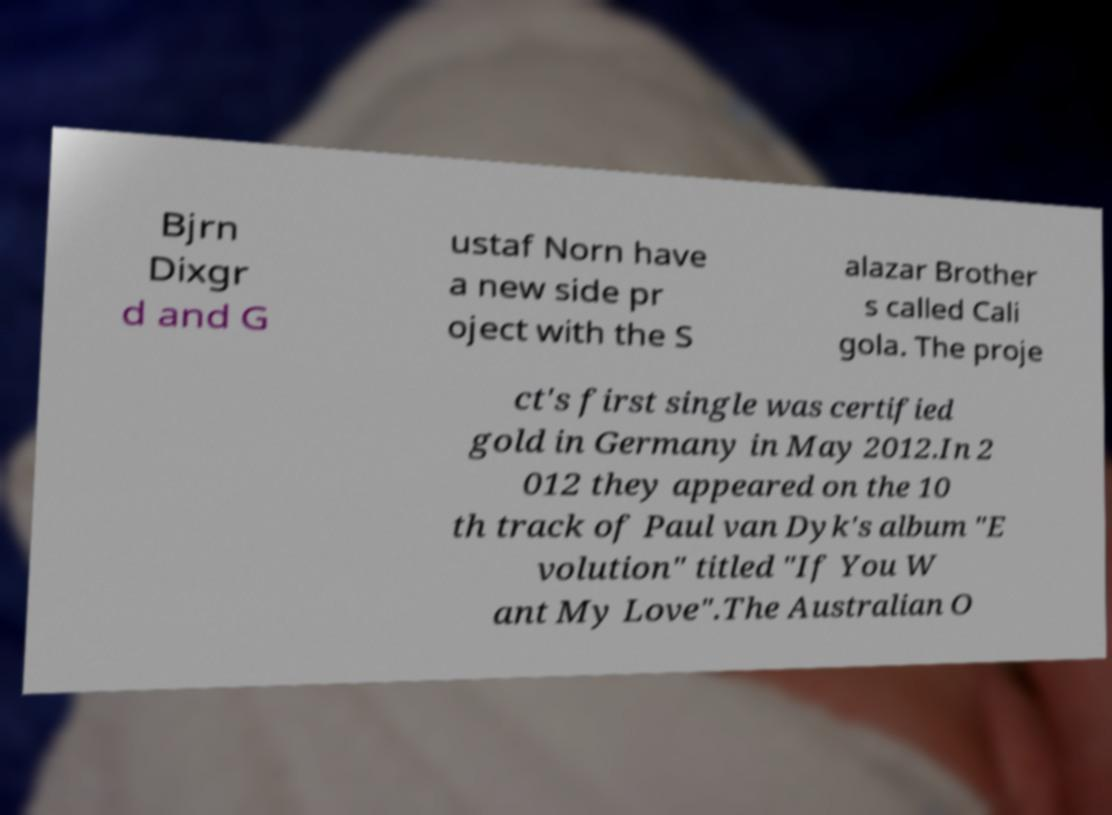Can you read and provide the text displayed in the image?This photo seems to have some interesting text. Can you extract and type it out for me? Bjrn Dixgr d and G ustaf Norn have a new side pr oject with the S alazar Brother s called Cali gola. The proje ct's first single was certified gold in Germany in May 2012.In 2 012 they appeared on the 10 th track of Paul van Dyk's album "E volution" titled "If You W ant My Love".The Australian O 